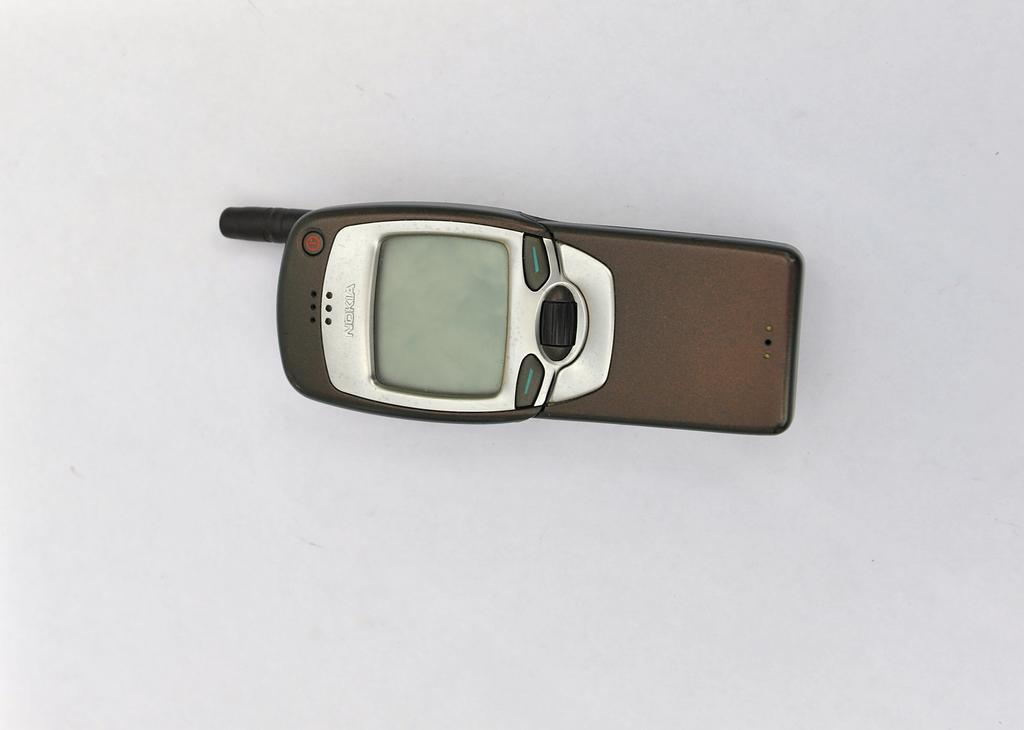<image>
Relay a brief, clear account of the picture shown. A nokia cell phone is laying on a white background. 